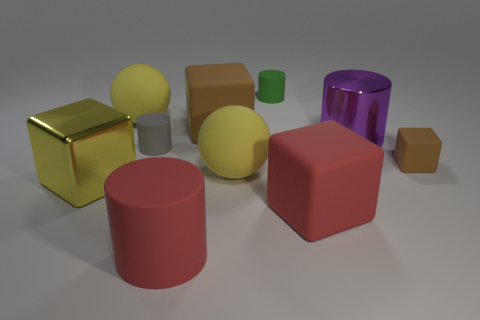How many yellow spheres have the same size as the gray matte thing?
Offer a terse response. 0. Do the small matte cylinder behind the tiny gray cylinder and the small cube have the same color?
Offer a terse response. No. There is a thing that is both on the right side of the large red cylinder and in front of the big yellow metal object; what material is it?
Make the answer very short. Rubber. Are there more large yellow spheres than purple shiny cylinders?
Your response must be concise. Yes. There is a matte cube in front of the brown object to the right of the metallic cylinder that is right of the tiny green rubber cylinder; what color is it?
Make the answer very short. Red. Does the small cylinder that is behind the large brown rubber thing have the same material as the big red cylinder?
Provide a succinct answer. Yes. Are there any shiny cubes that have the same color as the big matte cylinder?
Ensure brevity in your answer.  No. Are there any gray matte cylinders?
Make the answer very short. Yes. Does the brown matte block that is behind the gray rubber cylinder have the same size as the small green rubber cylinder?
Keep it short and to the point. No. Is the number of big cyan blocks less than the number of tiny things?
Give a very brief answer. Yes. 